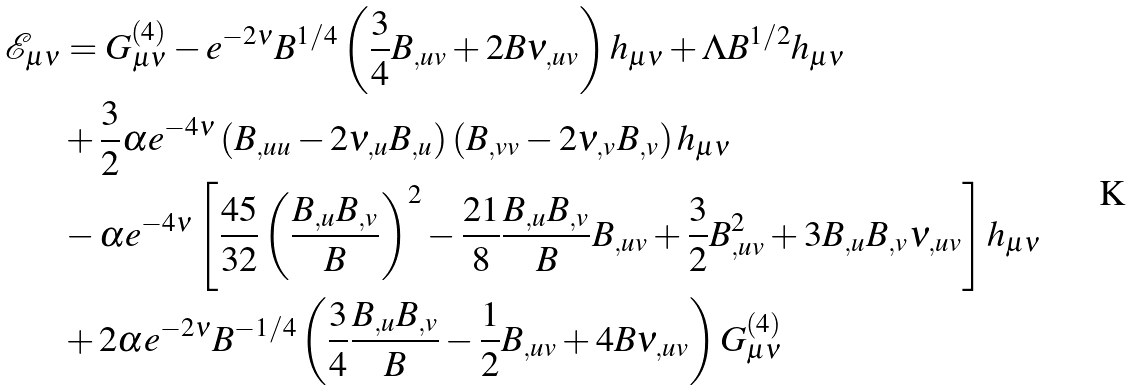Convert formula to latex. <formula><loc_0><loc_0><loc_500><loc_500>\mathcal { E } _ { \mu \nu } & = G _ { \mu \nu } ^ { ( 4 ) } - e ^ { - 2 \nu } B ^ { 1 / 4 } \left ( { \frac { 3 } { 4 } B _ { , u v } + 2 B \nu _ { , u v } } \right ) h _ { \mu \nu } + \Lambda B ^ { 1 / 2 } h _ { \mu \nu } \\ & + \frac { 3 } { 2 } \alpha e ^ { - 4 \nu } \left ( { B _ { , u u } - 2 \nu _ { , u } B _ { , u } } \right ) \left ( { B _ { , v v } - 2 \nu _ { , v } B _ { , v } } \right ) h _ { \mu \nu } \\ & - \alpha e ^ { - 4 \nu } \left [ { \frac { 4 5 } { 3 2 } \left ( { \frac { { B _ { , u } B _ { , v } } } { B } } \right ) ^ { 2 } - \frac { 2 1 } { 8 } \frac { { B _ { , u } B _ { , v } } } { B } B _ { , u v } + \frac { 3 } { 2 } B _ { , u v } ^ { 2 } + 3 B _ { , u } B _ { , v } \nu _ { , u v } } \right ] h _ { \mu \nu } \\ & + 2 \alpha e ^ { - 2 \nu } B ^ { - 1 / 4 } \left ( { \frac { 3 } { 4 } \frac { { B _ { , u } B _ { , v } } } { B } - \frac { 1 } { 2 } B _ { , u v } + 4 B \nu _ { , u v } } \right ) G _ { \mu \nu } ^ { ( 4 ) }</formula> 